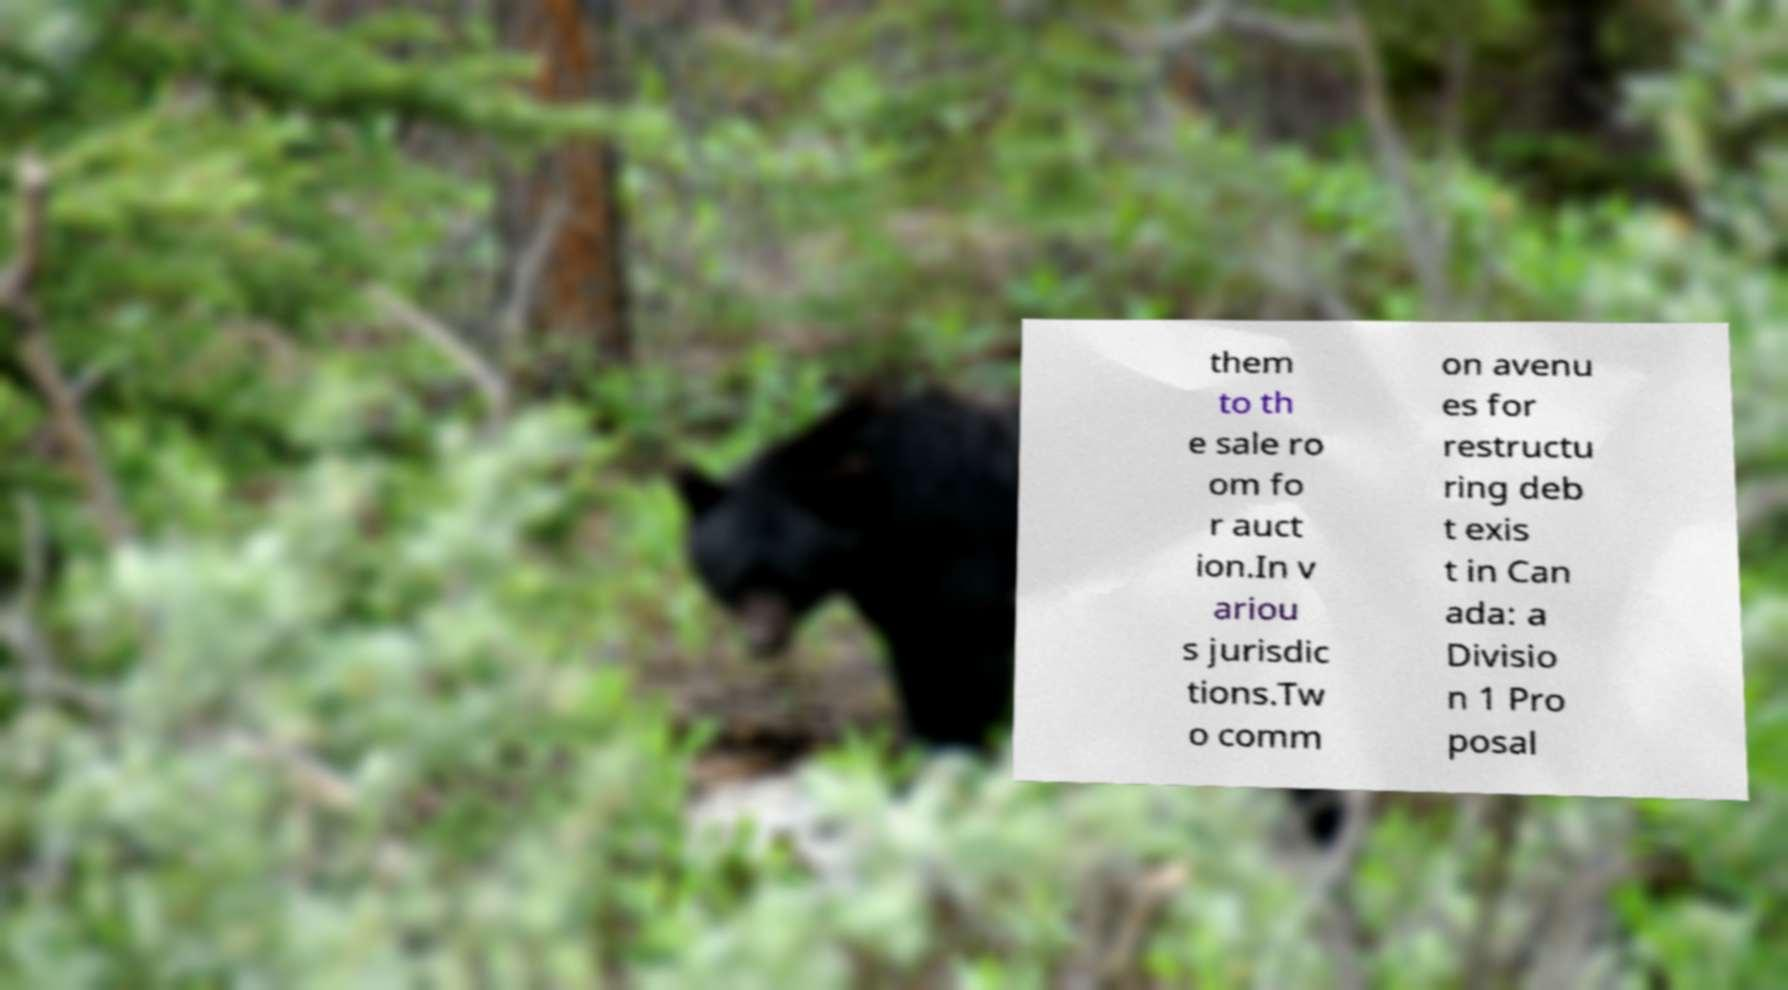Can you accurately transcribe the text from the provided image for me? them to th e sale ro om fo r auct ion.In v ariou s jurisdic tions.Tw o comm on avenu es for restructu ring deb t exis t in Can ada: a Divisio n 1 Pro posal 